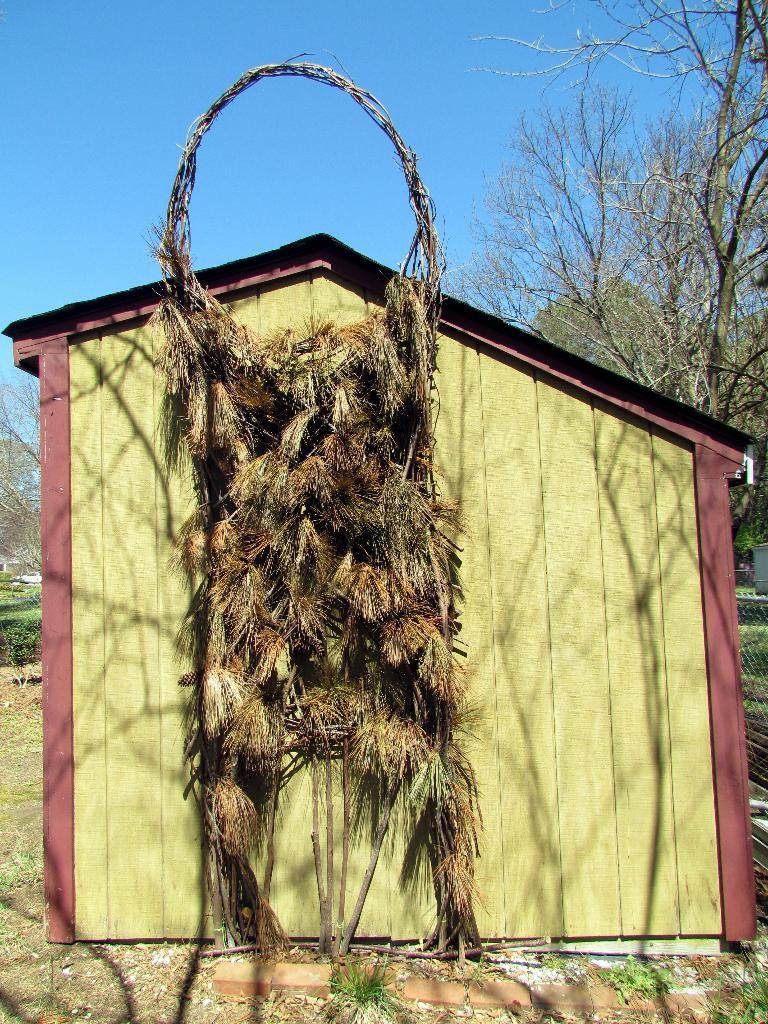What type of house is shown in the image? There is a wooden house in the image. What is hanging on the wooden house? There is a structure with dry grass hanging on the wooden house. What can be seen behind the wooden house? There are trees visible behind the wooden house. What is visible in the sky in the image? The sky is visible in the image. What committee is meeting in the wooden house in the image? There is no committee meeting in the wooden house in the image; it is a structure with dry grass hanging on it. 